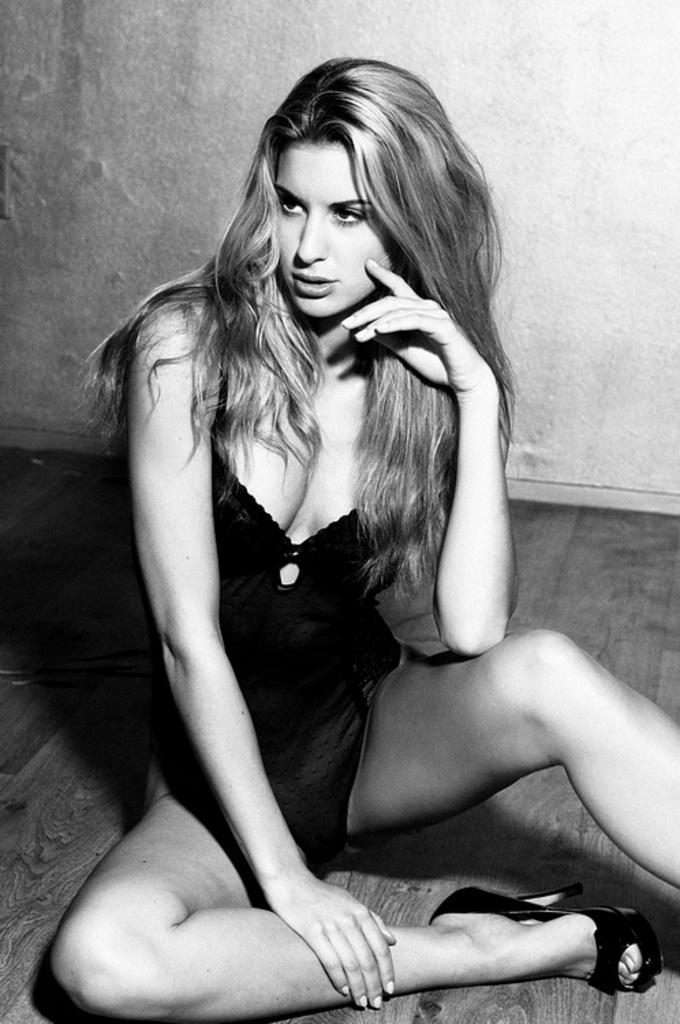What is the color scheme of the image? The image is black and white. Who is present in the image? There is a woman in the image. What is the woman wearing? The woman is wearing a dress and footwear. Where is the woman sitting? The woman is sitting on the wooden floor. What can be seen in the background of the image? There is a wall in the background of the image. What type of pear is the woman holding in the image? There is no pear present in the image. Can you tell me how many fish are swimming in the background of the image? There are no fish visible in the image; it is a black and white image with a woman sitting on the wooden floor and a wall in the background. 